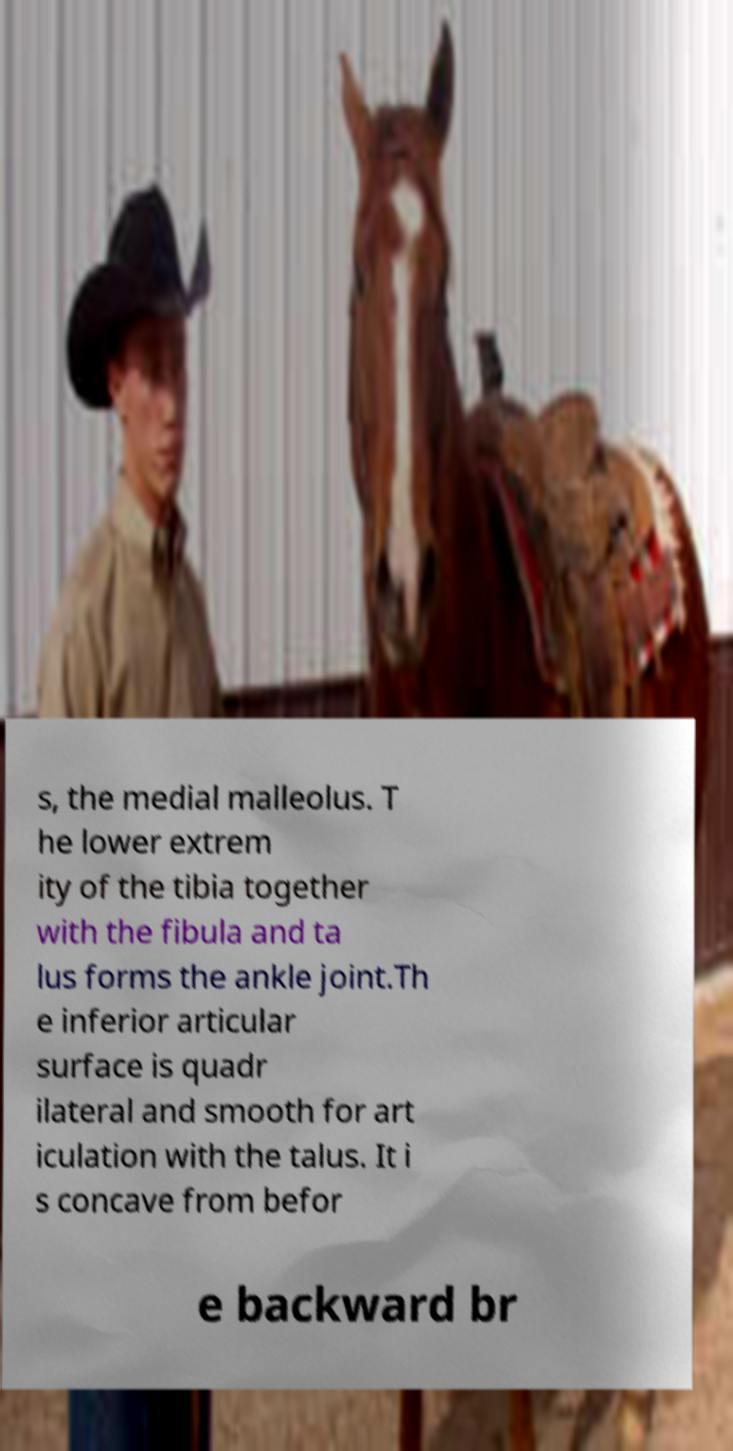Please identify and transcribe the text found in this image. s, the medial malleolus. T he lower extrem ity of the tibia together with the fibula and ta lus forms the ankle joint.Th e inferior articular surface is quadr ilateral and smooth for art iculation with the talus. It i s concave from befor e backward br 